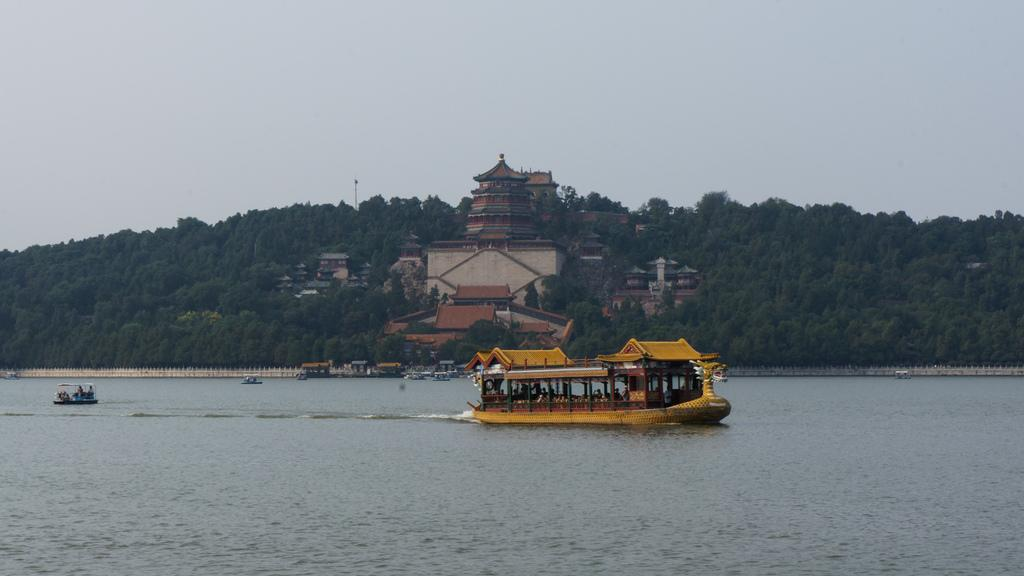What is in the water in the image? There is a boat in the water in the image. What color is the boat? The boat is yellow. What can be seen near the boat? There are constructions near the boat. What type of vegetation is beside the boat? There are green trees beside the boat. What is visible at the top of the image? The sky is visible at the top of the image. What type of sponge is being used to clean the boat in the image? There is no sponge present in the image, and the boat is not being cleaned. What team is operating the boat in the image? There is no team operating the boat in the image; it is stationary in the water. 